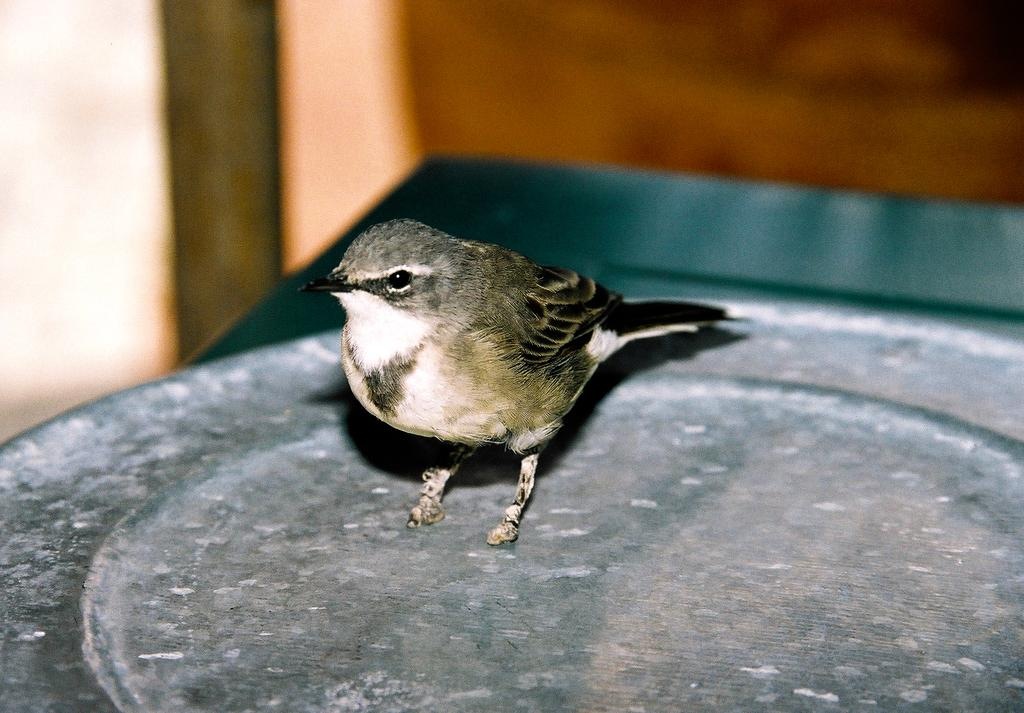What type of animal is in the image? There is a bird in the image. Can you describe the bird's coloring? The bird has white, grey, and black coloring. How would you describe the overall quality of the image? The image may be slightly blurry in the background. What type of insect can be seen crawling on the page in the image? There is no page or insect present in the image; it features a bird with white, grey, and black coloring. 